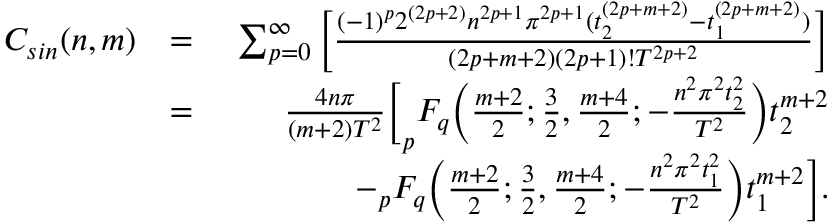<formula> <loc_0><loc_0><loc_500><loc_500>\begin{array} { r l r } { C _ { \sin } ( n , m ) } & { = } & { \sum _ { p = 0 } ^ { \infty } \left [ \frac { ( - 1 ) ^ { p } 2 ^ { ( 2 p + 2 ) } n ^ { 2 p + 1 } \pi ^ { 2 p + 1 } ( t _ { 2 } ^ { ( 2 p + m + 2 ) } - t _ { 1 } ^ { ( 2 p + m + 2 ) } ) } { ( 2 p + m + 2 ) ( 2 p + 1 ) ! T ^ { 2 p + 2 } } \right ] } \\ & { = } & { \frac { 4 n \pi } { ( m + 2 ) T ^ { 2 } } \left [ _ { p } F _ { q } \left ( \frac { m + 2 } { 2 } ; \frac { 3 } { 2 } , \frac { m + 4 } { 2 } ; - \frac { n ^ { 2 } \pi ^ { 2 } t _ { 2 } ^ { 2 } } { T ^ { 2 } } \right ) t _ { 2 } ^ { m + 2 } } \\ & { \quad } & { - _ { p } F _ { q } \left ( \frac { m + 2 } { 2 } ; \frac { 3 } { 2 } , \frac { m + 4 } { 2 } ; - \frac { n ^ { 2 } \pi ^ { 2 } t _ { 1 } ^ { 2 } } { T ^ { 2 } } \right ) t _ { 1 } ^ { m + 2 } \right ] . } \end{array}</formula> 